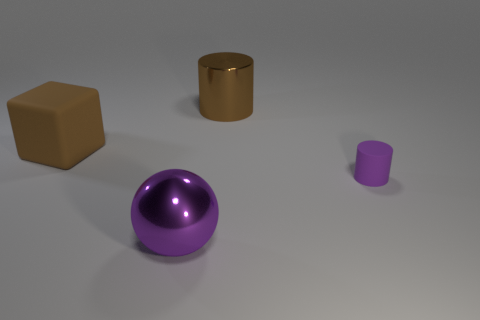Is there any other thing that has the same size as the purple cylinder?
Offer a very short reply. No. How big is the brown shiny cylinder?
Provide a short and direct response. Large. Is the color of the small object the same as the big shiny object that is in front of the big cylinder?
Give a very brief answer. Yes. There is a large brown thing to the right of the large object in front of the cylinder in front of the brown cube; what is it made of?
Ensure brevity in your answer.  Metal. There is a large thing that is behind the rubber cylinder and on the right side of the brown rubber object; what material is it made of?
Your answer should be very brief. Metal. How many large brown metallic objects are the same shape as the tiny object?
Give a very brief answer. 1. What size is the metallic cylinder to the right of the object to the left of the big purple thing?
Give a very brief answer. Large. There is a cylinder in front of the brown shiny thing; is it the same color as the thing in front of the tiny purple matte cylinder?
Keep it short and to the point. Yes. What number of metallic things are to the right of the cylinder behind the brown cube to the left of the big cylinder?
Provide a short and direct response. 0. How many big objects are both in front of the large brown shiny cylinder and behind the purple cylinder?
Your answer should be very brief. 1. 